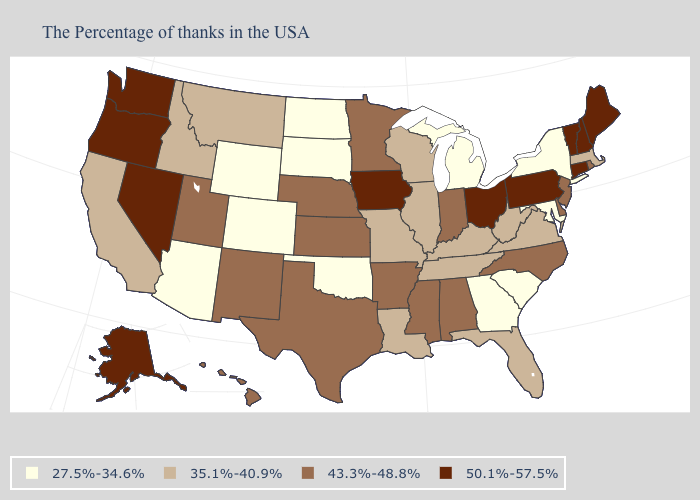Does Connecticut have the highest value in the USA?
Short answer required. Yes. What is the lowest value in the USA?
Write a very short answer. 27.5%-34.6%. Does Michigan have the lowest value in the MidWest?
Give a very brief answer. Yes. Does Pennsylvania have the same value as Washington?
Short answer required. Yes. What is the value of Utah?
Write a very short answer. 43.3%-48.8%. Name the states that have a value in the range 27.5%-34.6%?
Keep it brief. New York, Maryland, South Carolina, Georgia, Michigan, Oklahoma, South Dakota, North Dakota, Wyoming, Colorado, Arizona. What is the value of Maryland?
Give a very brief answer. 27.5%-34.6%. What is the value of Indiana?
Be succinct. 43.3%-48.8%. Among the states that border Florida , which have the highest value?
Write a very short answer. Alabama. Does Oklahoma have the lowest value in the USA?
Quick response, please. Yes. Is the legend a continuous bar?
Answer briefly. No. Name the states that have a value in the range 43.3%-48.8%?
Concise answer only. Rhode Island, New Jersey, Delaware, North Carolina, Indiana, Alabama, Mississippi, Arkansas, Minnesota, Kansas, Nebraska, Texas, New Mexico, Utah, Hawaii. What is the lowest value in the West?
Write a very short answer. 27.5%-34.6%. Name the states that have a value in the range 50.1%-57.5%?
Give a very brief answer. Maine, New Hampshire, Vermont, Connecticut, Pennsylvania, Ohio, Iowa, Nevada, Washington, Oregon, Alaska. Does Wisconsin have the same value as North Carolina?
Give a very brief answer. No. 